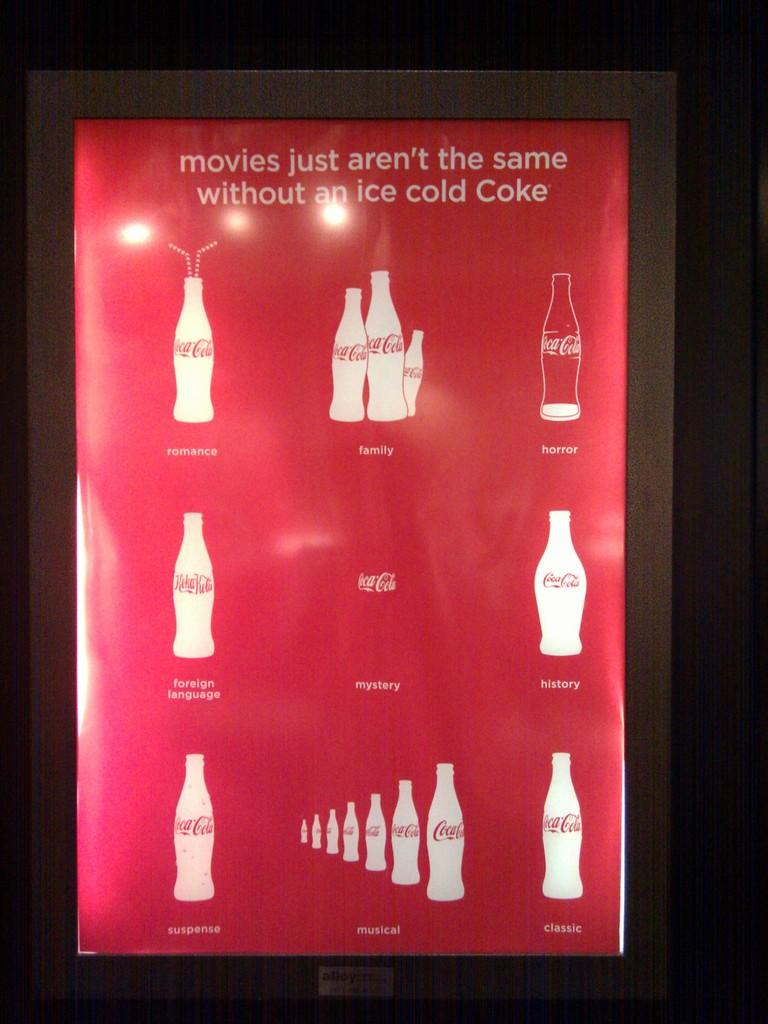<image>
Describe the image concisely. An advertisement for Coke lists various genres of movies. 